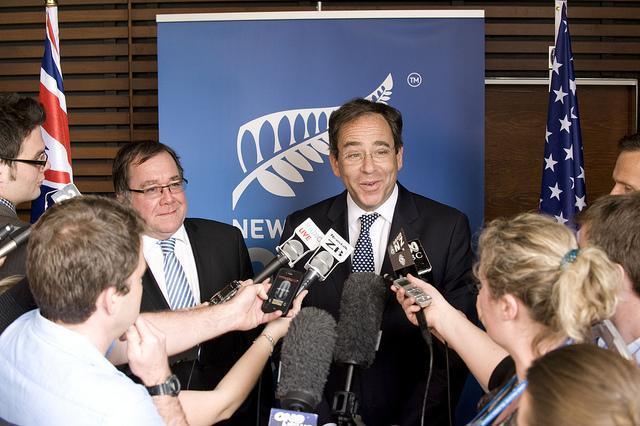How many people are there?
Give a very brief answer. 7. 